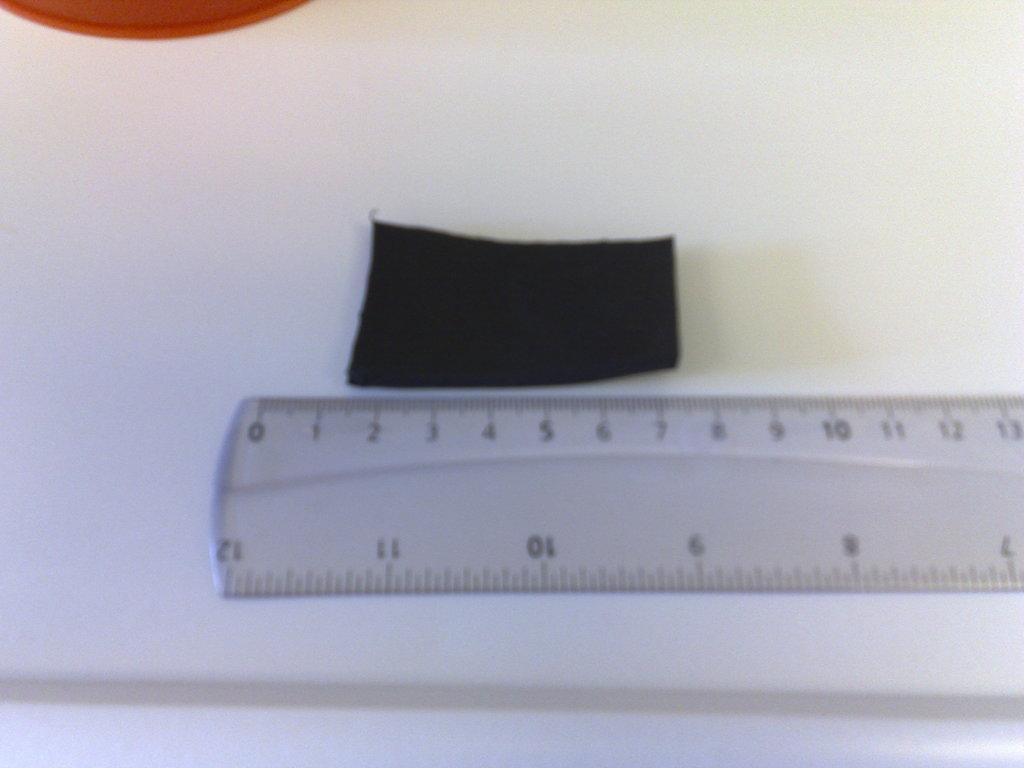How many inches is the longest this ruler extends to?
Give a very brief answer. 12. How many centimeters is the black rectangle?
Ensure brevity in your answer.  6. 